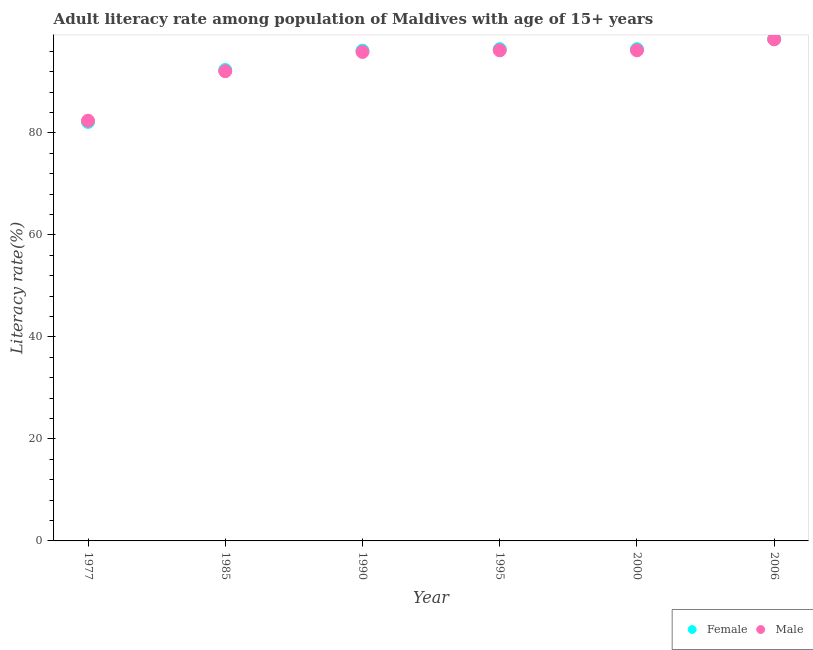How many different coloured dotlines are there?
Make the answer very short. 2. Is the number of dotlines equal to the number of legend labels?
Your answer should be very brief. Yes. What is the female adult literacy rate in 1995?
Offer a terse response. 96.44. Across all years, what is the maximum male adult literacy rate?
Provide a succinct answer. 98.37. Across all years, what is the minimum male adult literacy rate?
Ensure brevity in your answer.  82.4. What is the total female adult literacy rate in the graph?
Offer a terse response. 562. What is the difference between the female adult literacy rate in 1995 and that in 2006?
Ensure brevity in your answer.  -1.99. What is the difference between the male adult literacy rate in 2000 and the female adult literacy rate in 1995?
Provide a succinct answer. -0.23. What is the average male adult literacy rate per year?
Make the answer very short. 93.53. In the year 1985, what is the difference between the female adult literacy rate and male adult literacy rate?
Offer a terse response. 0.25. What is the ratio of the male adult literacy rate in 1977 to that in 2006?
Give a very brief answer. 0.84. Is the female adult literacy rate in 1985 less than that in 1995?
Your answer should be compact. Yes. Is the difference between the male adult literacy rate in 1985 and 2000 greater than the difference between the female adult literacy rate in 1985 and 2000?
Your answer should be compact. No. What is the difference between the highest and the second highest female adult literacy rate?
Offer a very short reply. 1.99. What is the difference between the highest and the lowest male adult literacy rate?
Offer a terse response. 15.96. In how many years, is the female adult literacy rate greater than the average female adult literacy rate taken over all years?
Offer a very short reply. 4. Is the sum of the female adult literacy rate in 1990 and 1995 greater than the maximum male adult literacy rate across all years?
Keep it short and to the point. Yes. Is the female adult literacy rate strictly greater than the male adult literacy rate over the years?
Provide a short and direct response. No. How many dotlines are there?
Provide a short and direct response. 2. How many years are there in the graph?
Your answer should be very brief. 6. Are the values on the major ticks of Y-axis written in scientific E-notation?
Provide a succinct answer. No. How many legend labels are there?
Ensure brevity in your answer.  2. How are the legend labels stacked?
Offer a terse response. Horizontal. What is the title of the graph?
Provide a succinct answer. Adult literacy rate among population of Maldives with age of 15+ years. What is the label or title of the X-axis?
Keep it short and to the point. Year. What is the label or title of the Y-axis?
Ensure brevity in your answer.  Literacy rate(%). What is the Literacy rate(%) of Female in 1977?
Keep it short and to the point. 82.18. What is the Literacy rate(%) of Male in 1977?
Your answer should be very brief. 82.4. What is the Literacy rate(%) of Female in 1985?
Ensure brevity in your answer.  92.36. What is the Literacy rate(%) in Male in 1985?
Your answer should be very brief. 92.11. What is the Literacy rate(%) in Female in 1990?
Your answer should be compact. 96.15. What is the Literacy rate(%) of Male in 1990?
Make the answer very short. 95.9. What is the Literacy rate(%) in Female in 1995?
Your answer should be very brief. 96.44. What is the Literacy rate(%) of Male in 1995?
Make the answer very short. 96.21. What is the Literacy rate(%) of Female in 2000?
Provide a succinct answer. 96.44. What is the Literacy rate(%) of Male in 2000?
Your answer should be very brief. 96.21. What is the Literacy rate(%) in Female in 2006?
Make the answer very short. 98.43. What is the Literacy rate(%) in Male in 2006?
Give a very brief answer. 98.37. Across all years, what is the maximum Literacy rate(%) in Female?
Your response must be concise. 98.43. Across all years, what is the maximum Literacy rate(%) of Male?
Offer a very short reply. 98.37. Across all years, what is the minimum Literacy rate(%) of Female?
Provide a succinct answer. 82.18. Across all years, what is the minimum Literacy rate(%) of Male?
Keep it short and to the point. 82.4. What is the total Literacy rate(%) of Female in the graph?
Make the answer very short. 562. What is the total Literacy rate(%) in Male in the graph?
Provide a succinct answer. 561.21. What is the difference between the Literacy rate(%) of Female in 1977 and that in 1985?
Offer a terse response. -10.18. What is the difference between the Literacy rate(%) of Male in 1977 and that in 1985?
Your answer should be very brief. -9.71. What is the difference between the Literacy rate(%) in Female in 1977 and that in 1990?
Offer a terse response. -13.97. What is the difference between the Literacy rate(%) in Male in 1977 and that in 1990?
Your answer should be compact. -13.49. What is the difference between the Literacy rate(%) of Female in 1977 and that in 1995?
Provide a succinct answer. -14.26. What is the difference between the Literacy rate(%) of Male in 1977 and that in 1995?
Your response must be concise. -13.81. What is the difference between the Literacy rate(%) in Female in 1977 and that in 2000?
Offer a very short reply. -14.26. What is the difference between the Literacy rate(%) in Male in 1977 and that in 2000?
Keep it short and to the point. -13.81. What is the difference between the Literacy rate(%) in Female in 1977 and that in 2006?
Your response must be concise. -16.25. What is the difference between the Literacy rate(%) of Male in 1977 and that in 2006?
Keep it short and to the point. -15.96. What is the difference between the Literacy rate(%) of Female in 1985 and that in 1990?
Offer a very short reply. -3.79. What is the difference between the Literacy rate(%) of Male in 1985 and that in 1990?
Your response must be concise. -3.78. What is the difference between the Literacy rate(%) in Female in 1985 and that in 1995?
Make the answer very short. -4.08. What is the difference between the Literacy rate(%) in Male in 1985 and that in 1995?
Keep it short and to the point. -4.1. What is the difference between the Literacy rate(%) in Female in 1985 and that in 2000?
Your answer should be compact. -4.08. What is the difference between the Literacy rate(%) of Male in 1985 and that in 2000?
Make the answer very short. -4.1. What is the difference between the Literacy rate(%) of Female in 1985 and that in 2006?
Give a very brief answer. -6.07. What is the difference between the Literacy rate(%) in Male in 1985 and that in 2006?
Make the answer very short. -6.25. What is the difference between the Literacy rate(%) of Female in 1990 and that in 1995?
Make the answer very short. -0.3. What is the difference between the Literacy rate(%) in Male in 1990 and that in 1995?
Provide a succinct answer. -0.32. What is the difference between the Literacy rate(%) of Female in 1990 and that in 2000?
Keep it short and to the point. -0.3. What is the difference between the Literacy rate(%) of Male in 1990 and that in 2000?
Offer a terse response. -0.32. What is the difference between the Literacy rate(%) in Female in 1990 and that in 2006?
Your answer should be very brief. -2.28. What is the difference between the Literacy rate(%) of Male in 1990 and that in 2006?
Your answer should be very brief. -2.47. What is the difference between the Literacy rate(%) in Female in 1995 and that in 2000?
Offer a terse response. 0. What is the difference between the Literacy rate(%) in Male in 1995 and that in 2000?
Offer a terse response. -0. What is the difference between the Literacy rate(%) in Female in 1995 and that in 2006?
Give a very brief answer. -1.99. What is the difference between the Literacy rate(%) of Male in 1995 and that in 2006?
Provide a succinct answer. -2.15. What is the difference between the Literacy rate(%) of Female in 2000 and that in 2006?
Your response must be concise. -1.99. What is the difference between the Literacy rate(%) in Male in 2000 and that in 2006?
Your answer should be very brief. -2.15. What is the difference between the Literacy rate(%) of Female in 1977 and the Literacy rate(%) of Male in 1985?
Offer a terse response. -9.94. What is the difference between the Literacy rate(%) in Female in 1977 and the Literacy rate(%) in Male in 1990?
Ensure brevity in your answer.  -13.72. What is the difference between the Literacy rate(%) in Female in 1977 and the Literacy rate(%) in Male in 1995?
Your response must be concise. -14.03. What is the difference between the Literacy rate(%) in Female in 1977 and the Literacy rate(%) in Male in 2000?
Give a very brief answer. -14.03. What is the difference between the Literacy rate(%) in Female in 1977 and the Literacy rate(%) in Male in 2006?
Keep it short and to the point. -16.19. What is the difference between the Literacy rate(%) of Female in 1985 and the Literacy rate(%) of Male in 1990?
Offer a terse response. -3.54. What is the difference between the Literacy rate(%) of Female in 1985 and the Literacy rate(%) of Male in 1995?
Keep it short and to the point. -3.85. What is the difference between the Literacy rate(%) of Female in 1985 and the Literacy rate(%) of Male in 2000?
Give a very brief answer. -3.85. What is the difference between the Literacy rate(%) of Female in 1985 and the Literacy rate(%) of Male in 2006?
Offer a very short reply. -6.01. What is the difference between the Literacy rate(%) in Female in 1990 and the Literacy rate(%) in Male in 1995?
Provide a succinct answer. -0.07. What is the difference between the Literacy rate(%) of Female in 1990 and the Literacy rate(%) of Male in 2000?
Make the answer very short. -0.07. What is the difference between the Literacy rate(%) in Female in 1990 and the Literacy rate(%) in Male in 2006?
Keep it short and to the point. -2.22. What is the difference between the Literacy rate(%) of Female in 1995 and the Literacy rate(%) of Male in 2000?
Offer a terse response. 0.23. What is the difference between the Literacy rate(%) in Female in 1995 and the Literacy rate(%) in Male in 2006?
Offer a very short reply. -1.92. What is the difference between the Literacy rate(%) of Female in 2000 and the Literacy rate(%) of Male in 2006?
Your response must be concise. -1.92. What is the average Literacy rate(%) in Female per year?
Keep it short and to the point. 93.67. What is the average Literacy rate(%) in Male per year?
Keep it short and to the point. 93.53. In the year 1977, what is the difference between the Literacy rate(%) of Female and Literacy rate(%) of Male?
Ensure brevity in your answer.  -0.23. In the year 1985, what is the difference between the Literacy rate(%) of Female and Literacy rate(%) of Male?
Offer a very short reply. 0.24. In the year 1990, what is the difference between the Literacy rate(%) in Female and Literacy rate(%) in Male?
Make the answer very short. 0.25. In the year 1995, what is the difference between the Literacy rate(%) of Female and Literacy rate(%) of Male?
Provide a short and direct response. 0.23. In the year 2000, what is the difference between the Literacy rate(%) in Female and Literacy rate(%) in Male?
Keep it short and to the point. 0.23. In the year 2006, what is the difference between the Literacy rate(%) in Female and Literacy rate(%) in Male?
Provide a succinct answer. 0.06. What is the ratio of the Literacy rate(%) in Female in 1977 to that in 1985?
Give a very brief answer. 0.89. What is the ratio of the Literacy rate(%) in Male in 1977 to that in 1985?
Provide a succinct answer. 0.89. What is the ratio of the Literacy rate(%) in Female in 1977 to that in 1990?
Your answer should be compact. 0.85. What is the ratio of the Literacy rate(%) in Male in 1977 to that in 1990?
Your answer should be compact. 0.86. What is the ratio of the Literacy rate(%) in Female in 1977 to that in 1995?
Offer a very short reply. 0.85. What is the ratio of the Literacy rate(%) of Male in 1977 to that in 1995?
Your answer should be compact. 0.86. What is the ratio of the Literacy rate(%) of Female in 1977 to that in 2000?
Ensure brevity in your answer.  0.85. What is the ratio of the Literacy rate(%) in Male in 1977 to that in 2000?
Ensure brevity in your answer.  0.86. What is the ratio of the Literacy rate(%) of Female in 1977 to that in 2006?
Give a very brief answer. 0.83. What is the ratio of the Literacy rate(%) in Male in 1977 to that in 2006?
Your response must be concise. 0.84. What is the ratio of the Literacy rate(%) of Female in 1985 to that in 1990?
Make the answer very short. 0.96. What is the ratio of the Literacy rate(%) in Male in 1985 to that in 1990?
Keep it short and to the point. 0.96. What is the ratio of the Literacy rate(%) of Female in 1985 to that in 1995?
Provide a succinct answer. 0.96. What is the ratio of the Literacy rate(%) of Male in 1985 to that in 1995?
Give a very brief answer. 0.96. What is the ratio of the Literacy rate(%) in Female in 1985 to that in 2000?
Give a very brief answer. 0.96. What is the ratio of the Literacy rate(%) of Male in 1985 to that in 2000?
Offer a very short reply. 0.96. What is the ratio of the Literacy rate(%) in Female in 1985 to that in 2006?
Your answer should be compact. 0.94. What is the ratio of the Literacy rate(%) in Male in 1985 to that in 2006?
Your answer should be very brief. 0.94. What is the ratio of the Literacy rate(%) of Male in 1990 to that in 1995?
Your answer should be compact. 1. What is the ratio of the Literacy rate(%) of Female in 1990 to that in 2000?
Your answer should be compact. 1. What is the ratio of the Literacy rate(%) of Male in 1990 to that in 2000?
Offer a very short reply. 1. What is the ratio of the Literacy rate(%) of Female in 1990 to that in 2006?
Offer a terse response. 0.98. What is the ratio of the Literacy rate(%) in Male in 1990 to that in 2006?
Ensure brevity in your answer.  0.97. What is the ratio of the Literacy rate(%) of Female in 1995 to that in 2000?
Your response must be concise. 1. What is the ratio of the Literacy rate(%) of Male in 1995 to that in 2000?
Offer a very short reply. 1. What is the ratio of the Literacy rate(%) in Female in 1995 to that in 2006?
Offer a terse response. 0.98. What is the ratio of the Literacy rate(%) of Male in 1995 to that in 2006?
Your response must be concise. 0.98. What is the ratio of the Literacy rate(%) in Female in 2000 to that in 2006?
Give a very brief answer. 0.98. What is the ratio of the Literacy rate(%) in Male in 2000 to that in 2006?
Your answer should be compact. 0.98. What is the difference between the highest and the second highest Literacy rate(%) of Female?
Ensure brevity in your answer.  1.99. What is the difference between the highest and the second highest Literacy rate(%) in Male?
Provide a succinct answer. 2.15. What is the difference between the highest and the lowest Literacy rate(%) in Female?
Keep it short and to the point. 16.25. What is the difference between the highest and the lowest Literacy rate(%) of Male?
Offer a terse response. 15.96. 